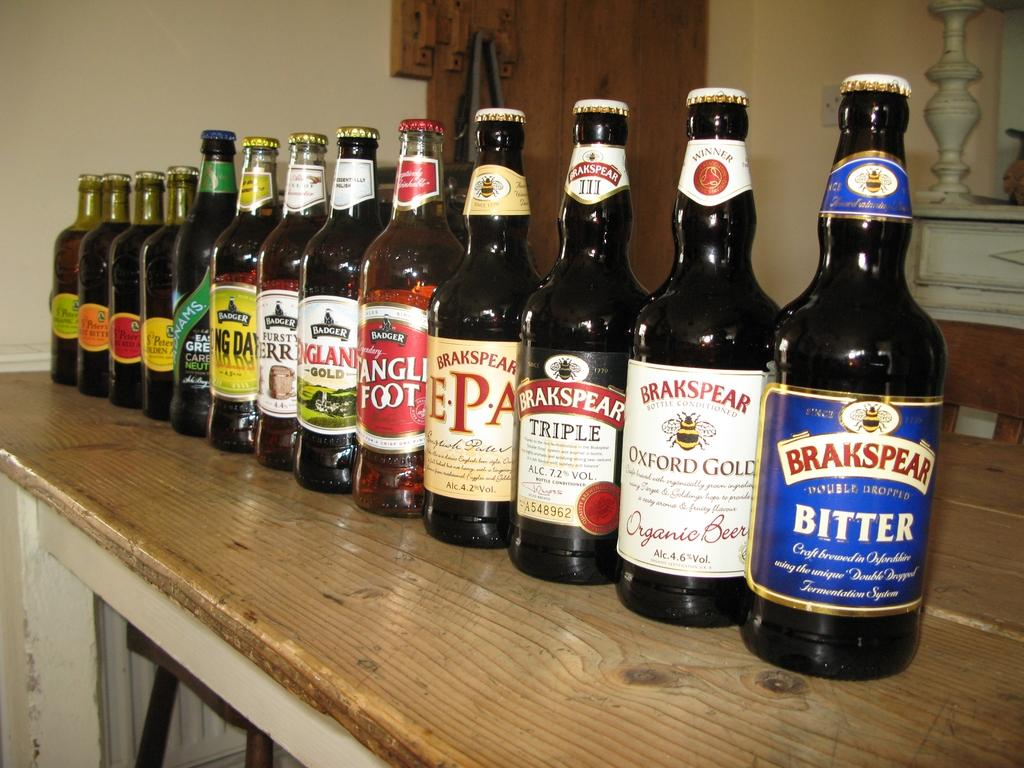Provide a one-sentence caption for the provided image. An assortment of beer bottles are lined up on a shelf, the first of which is Brakspear Bitter. 